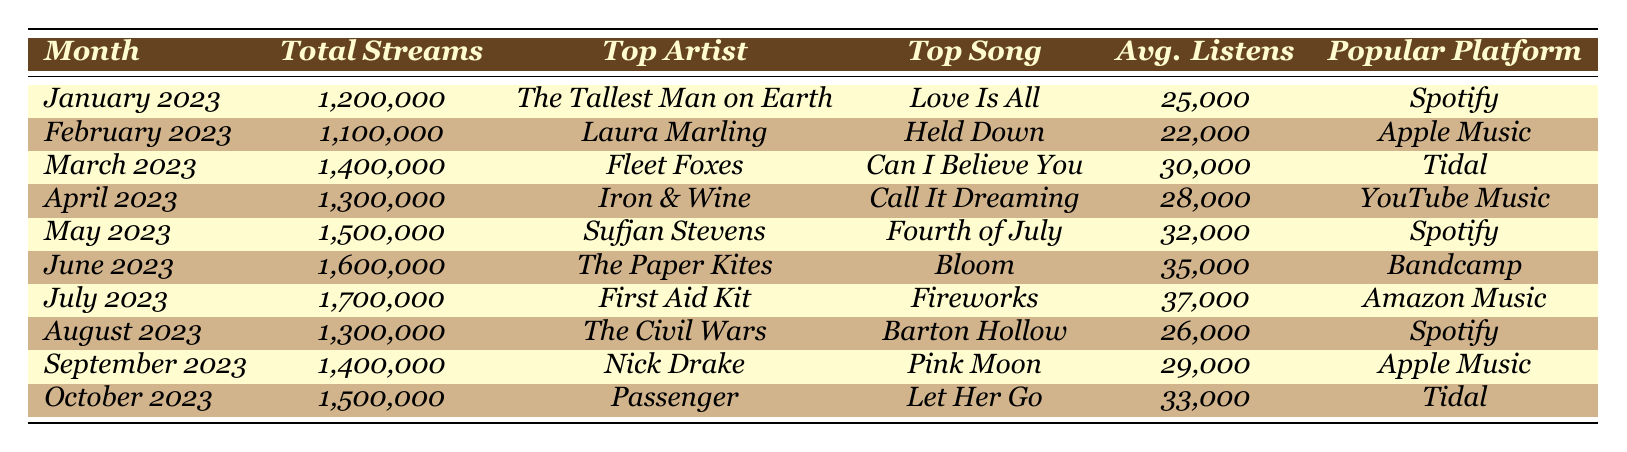What's the total number of streams for July 2023? The table shows that July 2023 has a total of 1,700,000 streams.
Answer: 1,700,000 Who was the top artist in June 2023? The table lists The Paper Kites as the top artist for June 2023.
Answer: The Paper Kites Which song had the highest average listens in the month of May 2023? In May 2023, the average listens for "Fourth of July" by Sufjan Stevens were 32,000, which is the highest for that month.
Answer: Fourth of July How many total streams were there from January to April 2023? The total streams for January (1,200,000), February (1,100,000), March (1,400,000), and April (1,300,000) sum to 4,000,000.
Answer: 4,000,000 Is the most popular platform for folk music streaming always Spotify? The table indicates that Spotify was not the most popular platform for February (Apple Music) and April (YouTube Music), making the statement false.
Answer: No What is the average number of listens for the top songs from January to July 2023? The average can be calculated by summing the average listens for January (25,000), February (22,000), March (30,000), April (28,000), May (32,000), June (35,000), and July (37,000), which equals 1,179,000. Dividing by 7 gives an average of 168,429.
Answer: 168,429 Which month had the highest total streams, and what is the value? According to the table, July 2023 had the highest total streams of 1,700,000.
Answer: July 2023, 1,700,000 What is the trend in total streams from January to October 2023? By observing the values in the table, total streams increased from January (1,200,000) to July (1,700,000) but dipped slightly in August (1,300,000), before rising again to 1,500,000 in October. Overall, there was a general upward trend with some fluctuations.
Answer: Increasing trend with fluctuations In which month did "Held Down" by Laura Marling receive the lowest average listens? The average listens for "Held Down" at 22,000 in February was lower than any other month's average.
Answer: February 2023 What is the total number of streams from June to October 2023? The total for June (1,600,000), July (1,700,000), August (1,300,000), September (1,400,000), and October (1,500,000) totals to 7,500,000 streams.
Answer: 7,500,000 